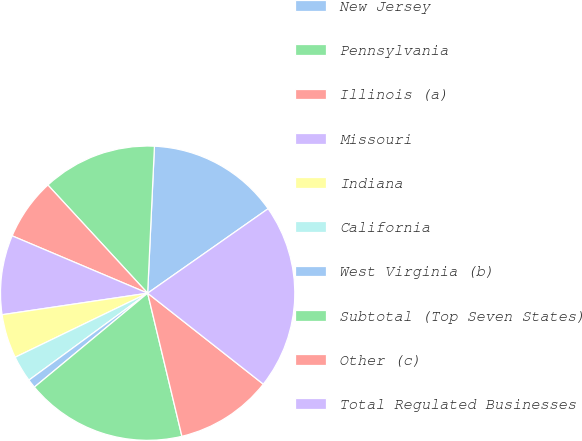Convert chart. <chart><loc_0><loc_0><loc_500><loc_500><pie_chart><fcel>New Jersey<fcel>Pennsylvania<fcel>Illinois (a)<fcel>Missouri<fcel>Indiana<fcel>California<fcel>West Virginia (b)<fcel>Subtotal (Top Seven States)<fcel>Other (c)<fcel>Total Regulated Businesses<nl><fcel>14.53%<fcel>12.59%<fcel>6.77%<fcel>8.71%<fcel>4.83%<fcel>2.89%<fcel>0.96%<fcel>17.72%<fcel>10.65%<fcel>20.34%<nl></chart> 